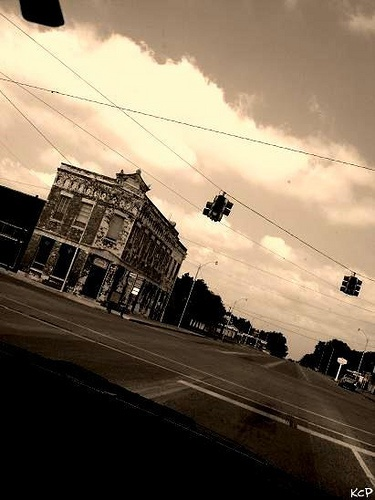Describe the objects in this image and their specific colors. I can see traffic light in gray, black, and darkgray tones, car in gray and black tones, traffic light in gray, black, and darkgray tones, traffic light in gray, black, and maroon tones, and car in gray and black tones in this image. 